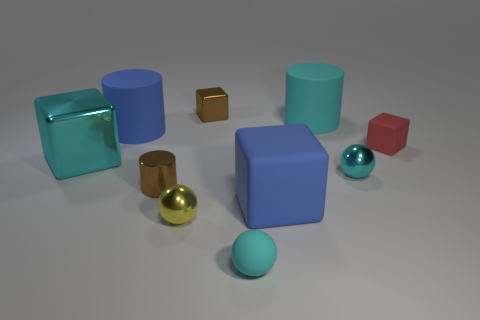What number of other tiny cylinders have the same color as the small shiny cylinder?
Your answer should be very brief. 0. The brown cube is what size?
Offer a terse response. Small. Is the yellow sphere the same size as the cyan matte cylinder?
Provide a short and direct response. No. What color is the thing that is in front of the cyan cube and on the left side of the yellow shiny ball?
Your answer should be very brief. Brown. How many purple blocks are the same material as the big blue block?
Give a very brief answer. 0. What number of tiny rubber cubes are there?
Your answer should be very brief. 1. Does the cyan matte ball have the same size as the metallic object that is behind the big metallic block?
Make the answer very short. Yes. There is a big cylinder that is on the right side of the shiny cylinder that is left of the brown metal cube; what is its material?
Your answer should be compact. Rubber. There is a cylinder that is to the right of the tiny rubber thing in front of the tiny block on the right side of the big cyan matte object; what is its size?
Your response must be concise. Large. Does the yellow metal thing have the same shape as the blue object on the left side of the tiny cyan rubber sphere?
Ensure brevity in your answer.  No. 